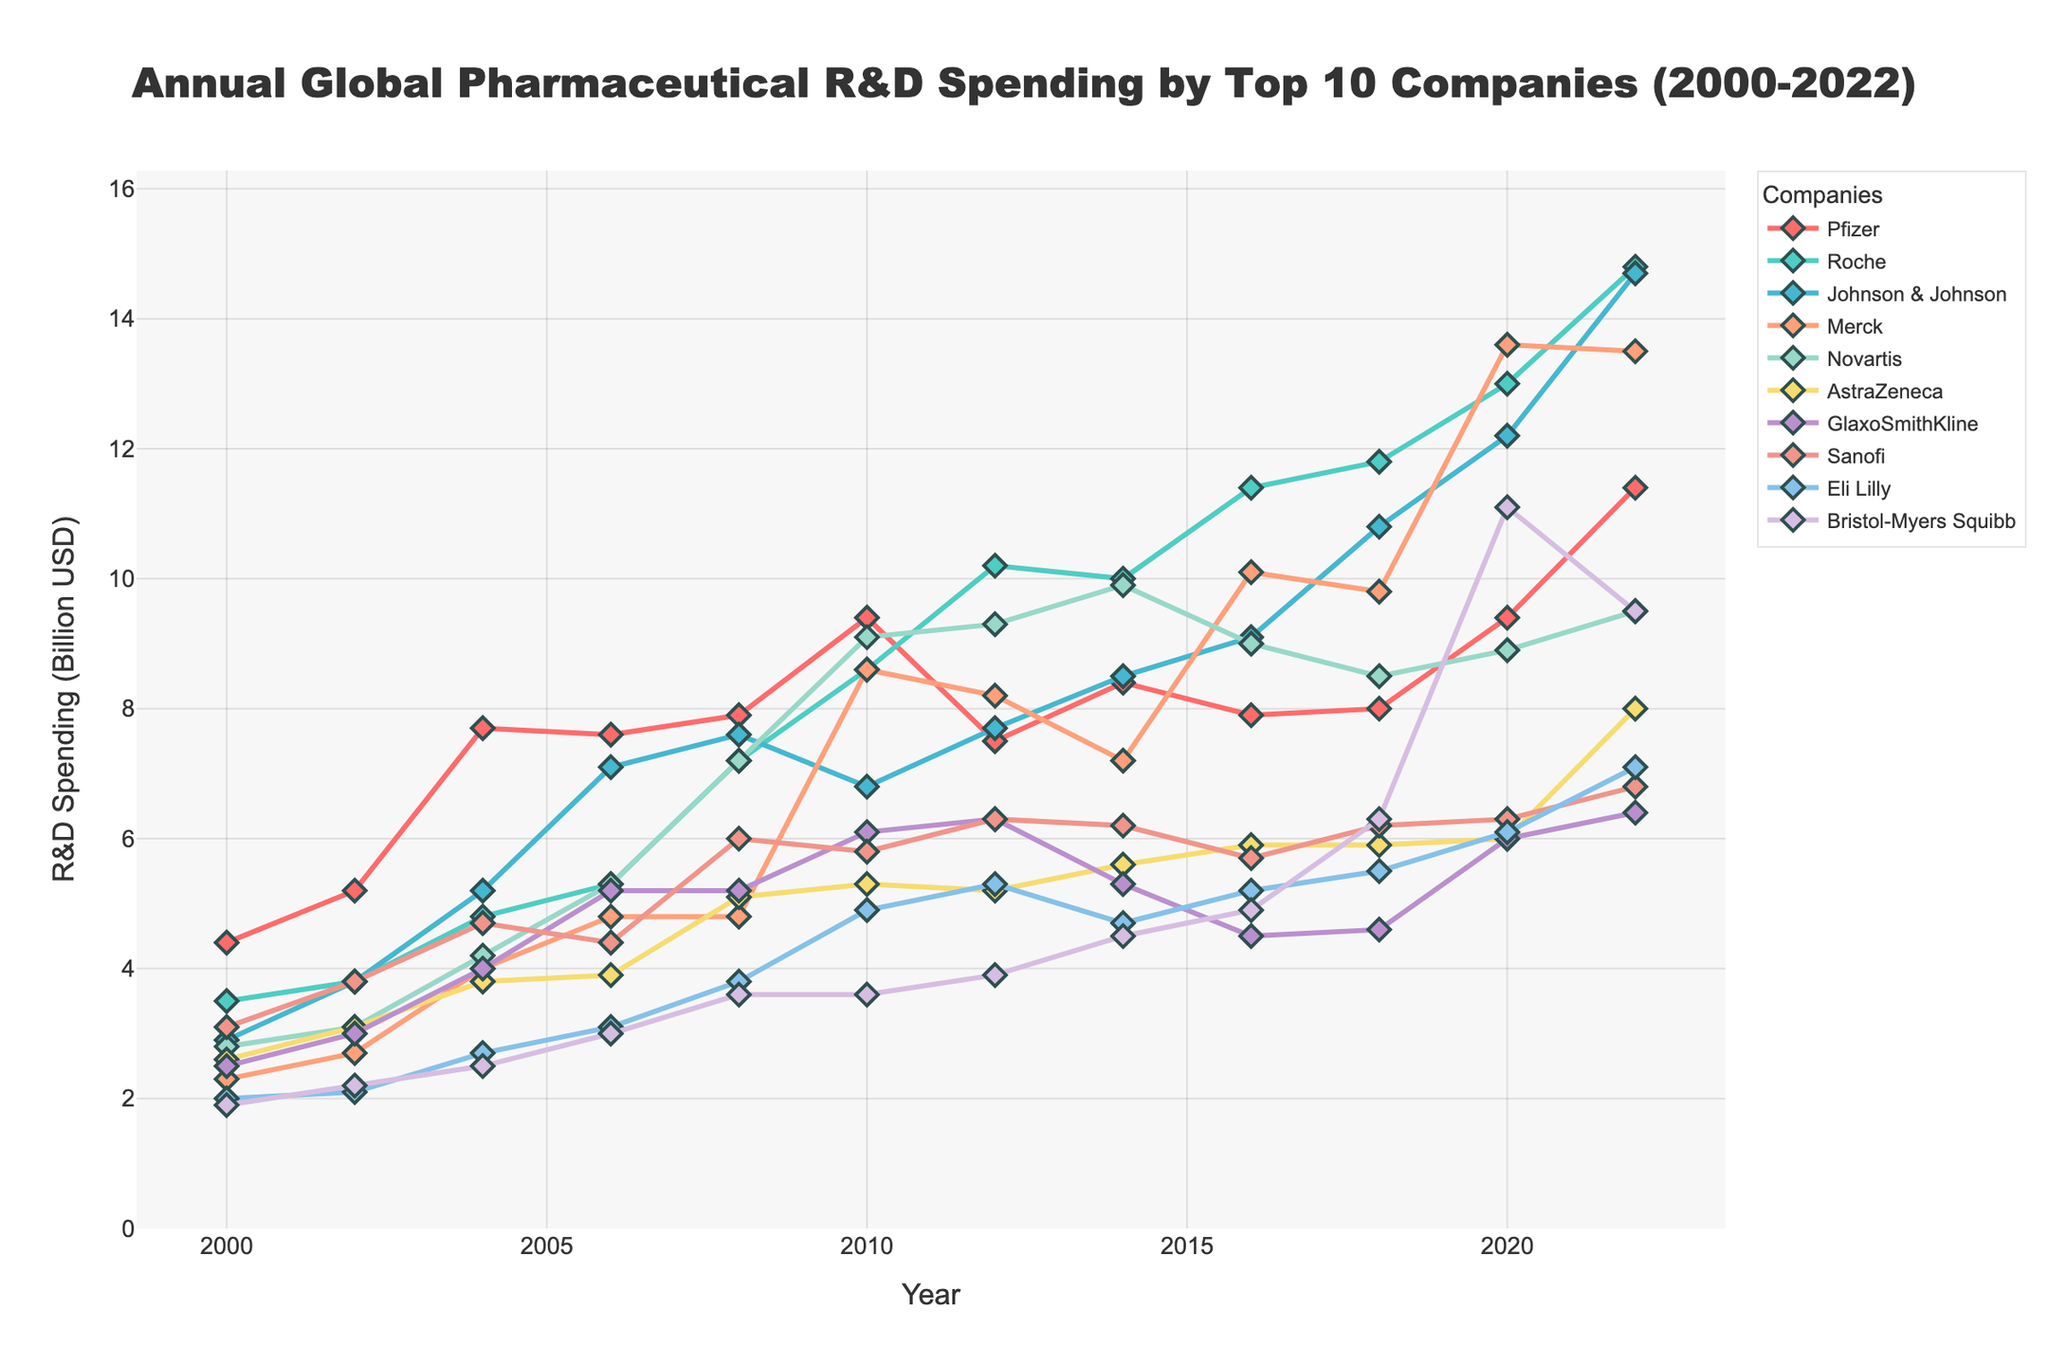What is the highest R&D spending recorded by any company according to the chart? According to the chart, the highest R&D spending recorded is by Roche in the year 2022 with a value of 14.8 billion USD.
Answer: 14.8 billion USD Compare the R&D spending trends of Pfizer and Roche between 2000 and 2022. Which company showed a greater overall increase? By looking at the chart, Pfizer's spending in 2000 was 4.4 billion USD and increased to 11.4 billion USD by 2022. Roche's spending in 2000 was 3.5 billion USD and increased to 14.8 billion USD by 2022. The difference for Pfizer is 7 billion USD, and for Roche, it is 11.3 billion USD. So, Roche showed a greater overall increase.
Answer: Roche In which year did Johnson & Johnson's R&D spending first surpass 10 billion USD? By observing the chart, Johnson & Johnson's R&D spending first surpasses 10 billion USD in the year 2018.
Answer: 2018 Between 2008 and 2012, which company showed a decrease in R&D spending? Observing the chart in the mentioned period, Pfizer's spending decreased from 7.9 billion USD in 2008 to 7.5 billion USD in 2012.
Answer: Pfizer What is the average R&D spending of Novartis between 2000 and 2022? The spending values for Novartis are 2.8, 3.1, 4.2, 5.3, 7.2, 9.1, 9.3, 9.9, 9.0, 8.5, 8.9, and 9.5 billion USD across the respective years. Sum these up and divide by the number of years: (2.8 + 3.1 + 4.2 + 5.3 + 7.2 + 9.1 + 9.3 + 9.9 + 9.0 + 8.5 + 8.9 + 9.5) / 12 = 7.217 billion USD.
Answer: 7.217 billion USD Which company had the least R&D spending in 2020, and how much was it? According to the chart, GlaxoSmithKline had the least R&D spending in 2020 with 6.0 billion USD.
Answer: GlaxoSmithKline, 6.0 billion USD How does the R&D spending of Bristol-Myers Squibb change from 2006 to 2022? Observing the chart, Bristol-Myers Squibb's spending increased steadily from 3.0 billion USD in 2006 to 9.5 billion USD in 2022.
Answer: Increased from 3.0 billion USD to 9.5 billion USD What is the total R&D spending by AstraZeneca from 2000 to 2022? The spending values for AstraZeneca are 2.6, 3.1, 3.8, 3.9, 5.1, 5.3, 5.2, 5.6, 5.9, 5.9, 6.0, and 8.0 billion USD across the respective years. Sum these up: 2.6 + 3.1 + 3.8 + 3.9 + 5.1 + 5.3 + 5.2 + 5.6 + 5.9 + 5.9 + 6.0 + 8.0 = 60.4 billion USD.
Answer: 60.4 billion USD Identify two companies whose R&D spending intersected in any year between 2000 and 2022. By inspecting the chart, Roche and Novartis had intersecting R&D spending in the year 2008, both at 7.2 billion USD.
Answer: Roche and Novartis 